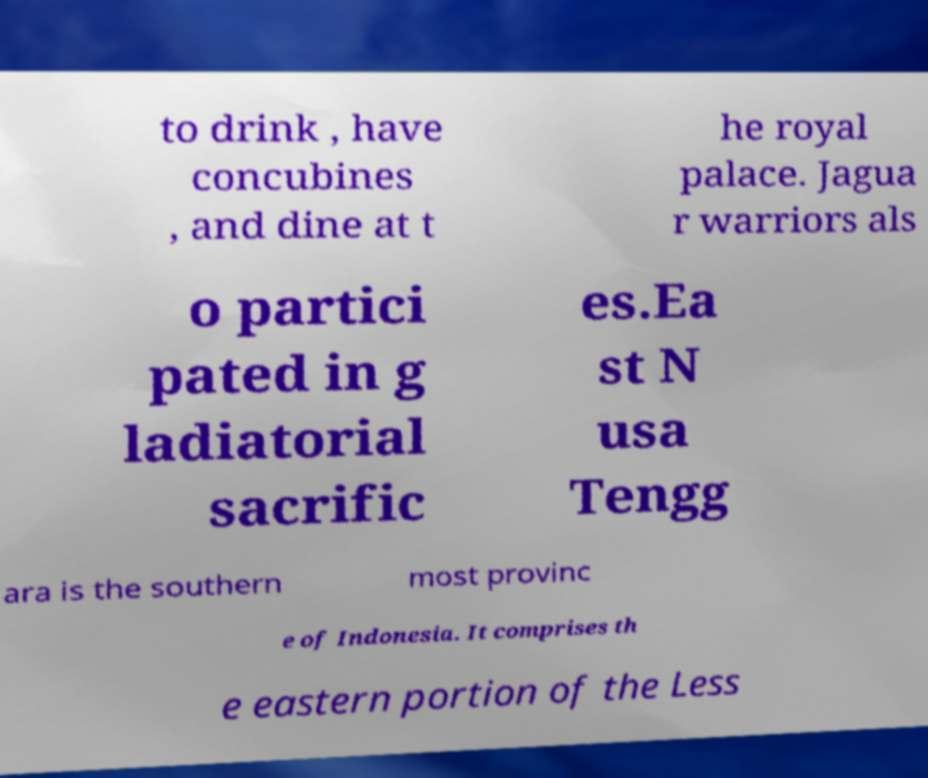Can you read and provide the text displayed in the image?This photo seems to have some interesting text. Can you extract and type it out for me? to drink , have concubines , and dine at t he royal palace. Jagua r warriors als o partici pated in g ladiatorial sacrific es.Ea st N usa Tengg ara is the southern most provinc e of Indonesia. It comprises th e eastern portion of the Less 